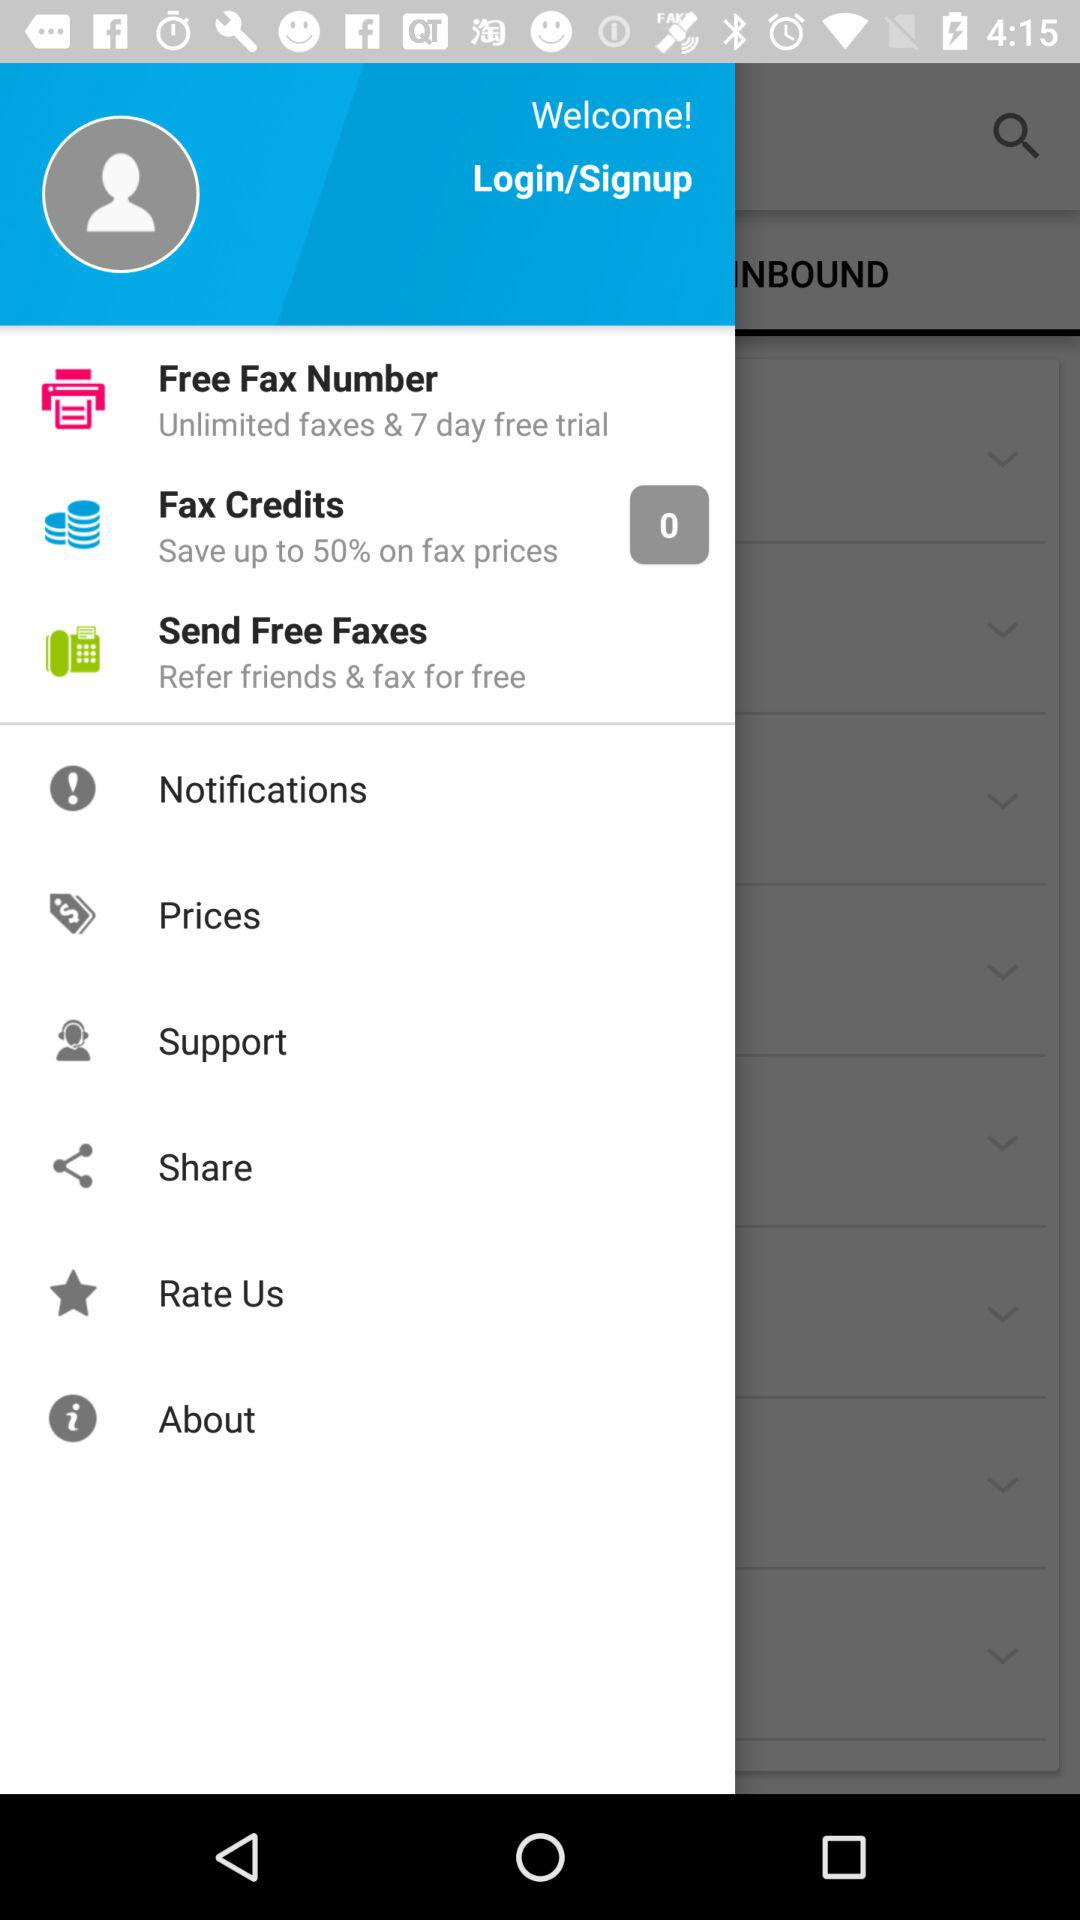How many notifications are there in "Fax Credits"? There are 0 notifications in "Fax Credits". 